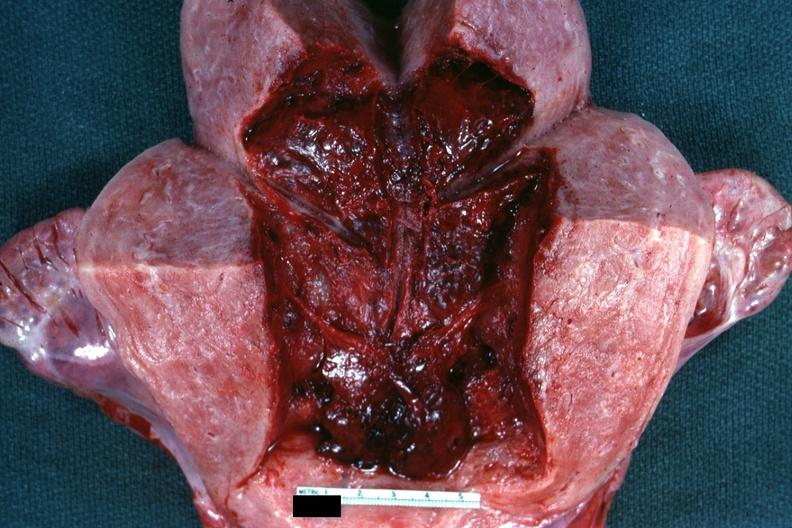does this image show 18 hours after cesarean section?
Answer the question using a single word or phrase. Yes 